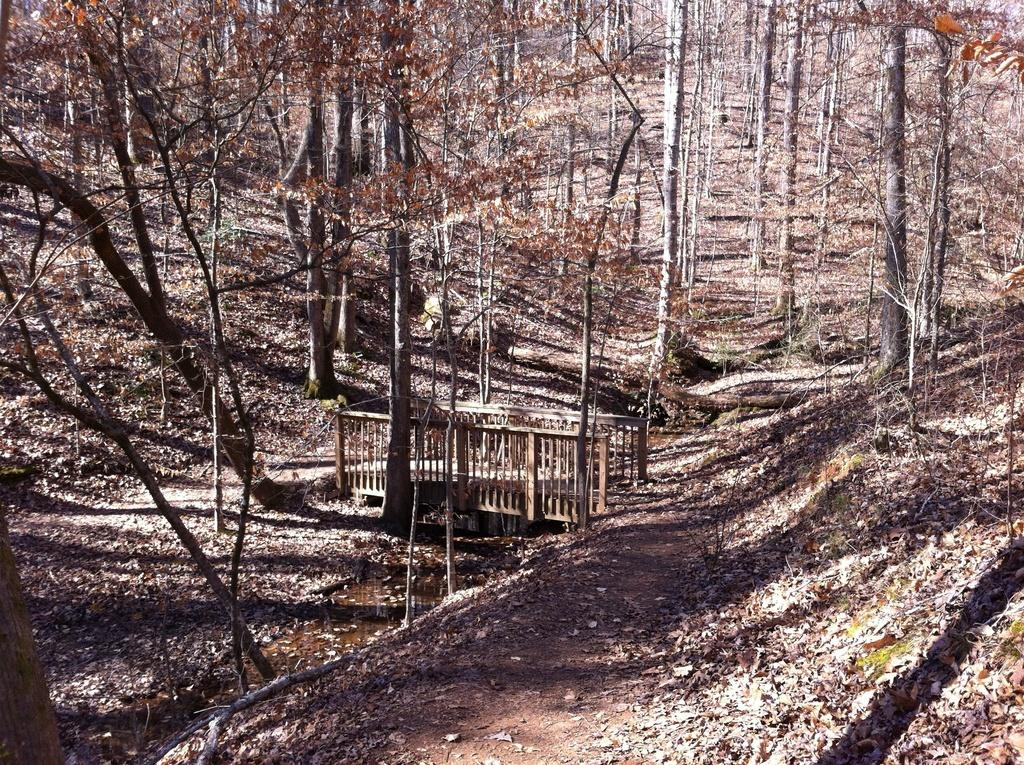What type of vegetation can be seen in the image? There are trees in the image. What structure is present in the image? There is a wooden bridge in the image. What can be found at the bottom of the image? Dried leaves are present at the bottom of the image. Can you tell me how many berries are on the wooden bridge in the image? There are no berries present on the wooden bridge in the image. Are there any police officers visible in the image? There is no mention of police officers in the provided facts, and therefore they cannot be confirmed to be present in the image. 